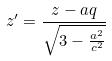Convert formula to latex. <formula><loc_0><loc_0><loc_500><loc_500>z ^ { \prime } = \frac { z - a q } { \sqrt { 3 - \frac { a ^ { 2 } } { c ^ { 2 } } } }</formula> 